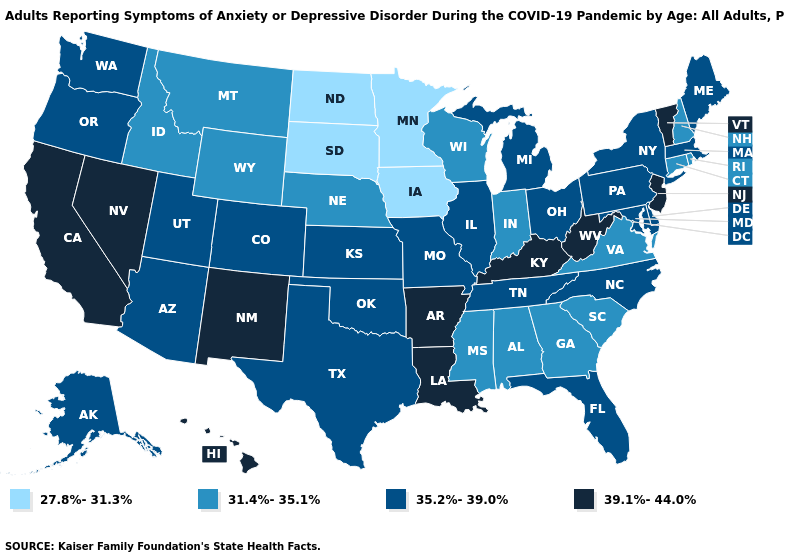What is the value of Oklahoma?
Concise answer only. 35.2%-39.0%. What is the highest value in the USA?
Write a very short answer. 39.1%-44.0%. Which states have the lowest value in the USA?
Answer briefly. Iowa, Minnesota, North Dakota, South Dakota. What is the lowest value in states that border Ohio?
Answer briefly. 31.4%-35.1%. Which states have the lowest value in the South?
Write a very short answer. Alabama, Georgia, Mississippi, South Carolina, Virginia. Does the first symbol in the legend represent the smallest category?
Concise answer only. Yes. Name the states that have a value in the range 39.1%-44.0%?
Keep it brief. Arkansas, California, Hawaii, Kentucky, Louisiana, Nevada, New Jersey, New Mexico, Vermont, West Virginia. Does Virginia have the same value as Hawaii?
Quick response, please. No. Name the states that have a value in the range 35.2%-39.0%?
Answer briefly. Alaska, Arizona, Colorado, Delaware, Florida, Illinois, Kansas, Maine, Maryland, Massachusetts, Michigan, Missouri, New York, North Carolina, Ohio, Oklahoma, Oregon, Pennsylvania, Tennessee, Texas, Utah, Washington. What is the value of Florida?
Give a very brief answer. 35.2%-39.0%. Is the legend a continuous bar?
Write a very short answer. No. What is the highest value in the MidWest ?
Quick response, please. 35.2%-39.0%. What is the lowest value in the South?
Give a very brief answer. 31.4%-35.1%. Among the states that border South Dakota , which have the lowest value?
Write a very short answer. Iowa, Minnesota, North Dakota. Which states have the highest value in the USA?
Write a very short answer. Arkansas, California, Hawaii, Kentucky, Louisiana, Nevada, New Jersey, New Mexico, Vermont, West Virginia. 